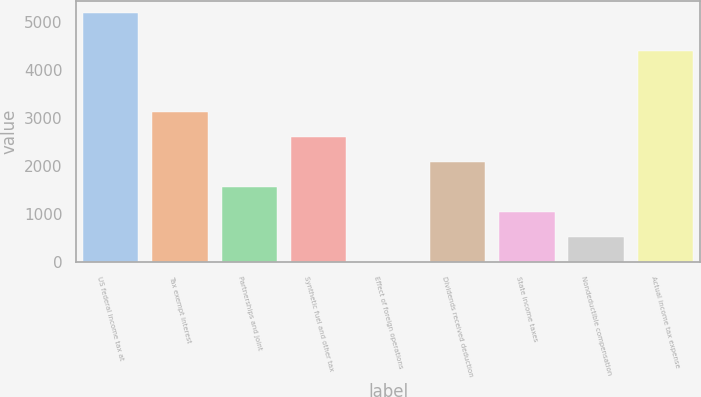Convert chart to OTSL. <chart><loc_0><loc_0><loc_500><loc_500><bar_chart><fcel>US federal income tax at<fcel>Tax exempt interest<fcel>Partnerships and joint<fcel>Synthetic fuel and other tax<fcel>Effect of foreign operations<fcel>Dividends received deduction<fcel>State income taxes<fcel>Nondeductible compensation<fcel>Actual income tax expense<nl><fcel>5197<fcel>3122.6<fcel>1566.8<fcel>2604<fcel>11<fcel>2085.4<fcel>1048.2<fcel>529.6<fcel>4407<nl></chart> 